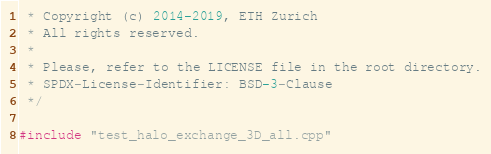<code> <loc_0><loc_0><loc_500><loc_500><_Cuda_> * Copyright (c) 2014-2019, ETH Zurich
 * All rights reserved.
 *
 * Please, refer to the LICENSE file in the root directory.
 * SPDX-License-Identifier: BSD-3-Clause
 */

#include "test_halo_exchange_3D_all.cpp"
</code> 